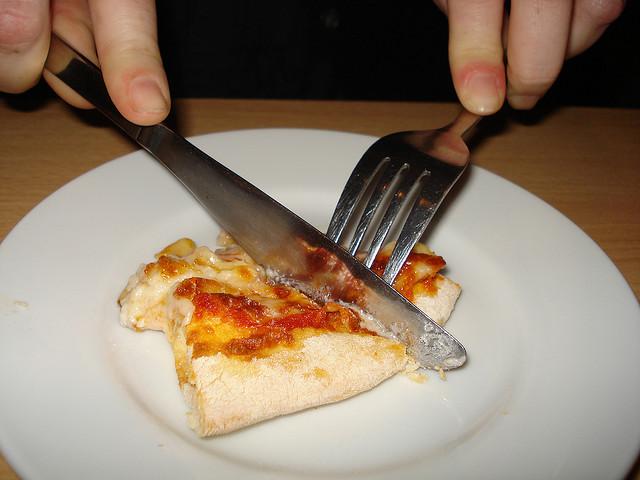What color is the plate?
Short answer required. White. What food is the person slicing?
Write a very short answer. Pizza. Does this person have bruised index finger?
Be succinct. Yes. 